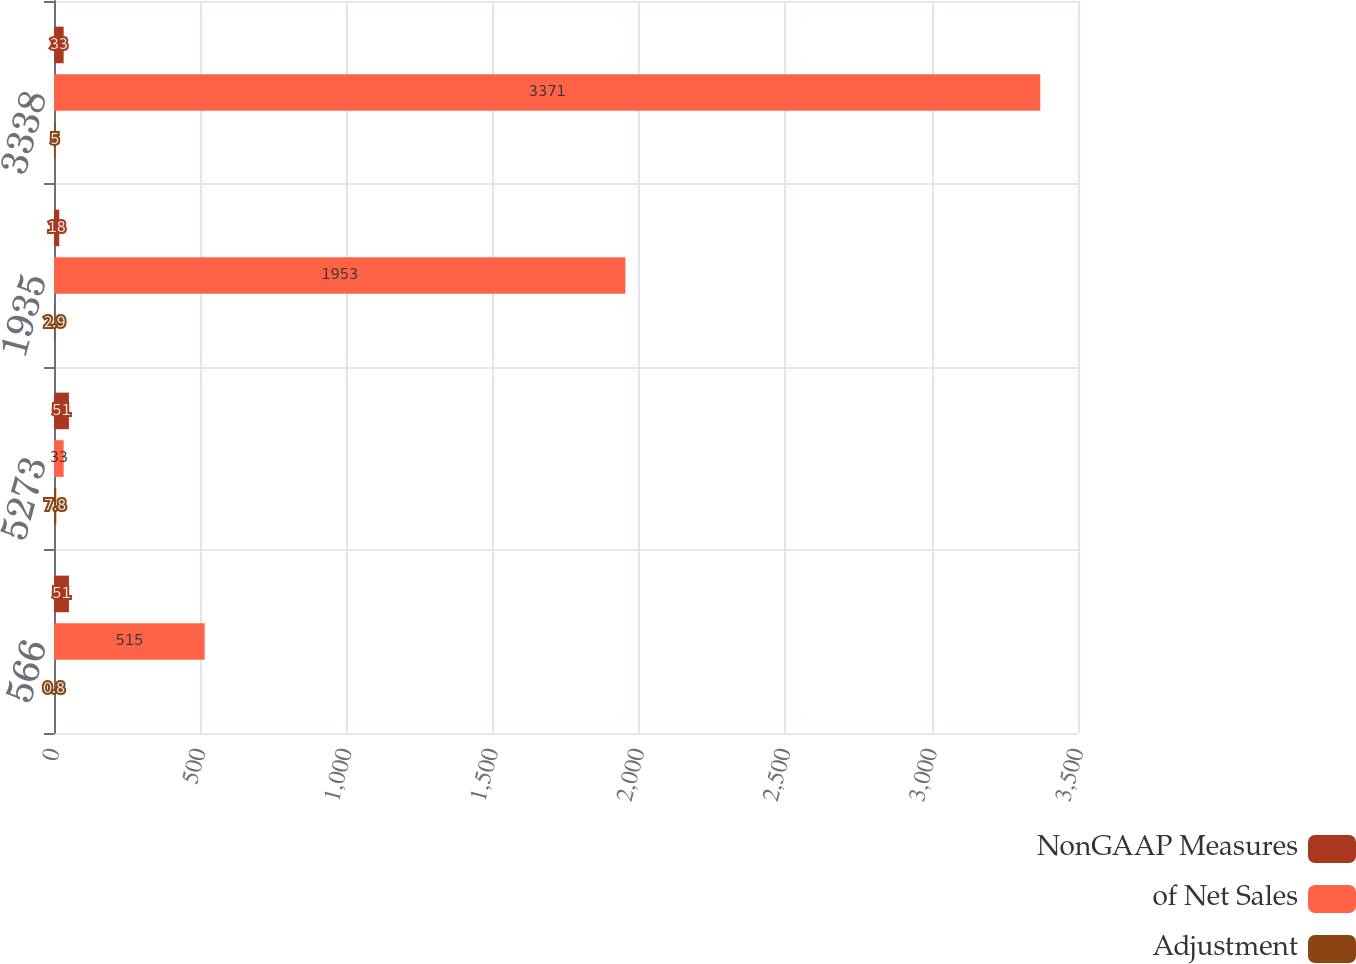Convert chart. <chart><loc_0><loc_0><loc_500><loc_500><stacked_bar_chart><ecel><fcel>566<fcel>5273<fcel>1935<fcel>3338<nl><fcel>NonGAAP Measures<fcel>51<fcel>51<fcel>18<fcel>33<nl><fcel>of Net Sales<fcel>515<fcel>33<fcel>1953<fcel>3371<nl><fcel>Adjustment<fcel>0.8<fcel>7.8<fcel>2.9<fcel>5<nl></chart> 